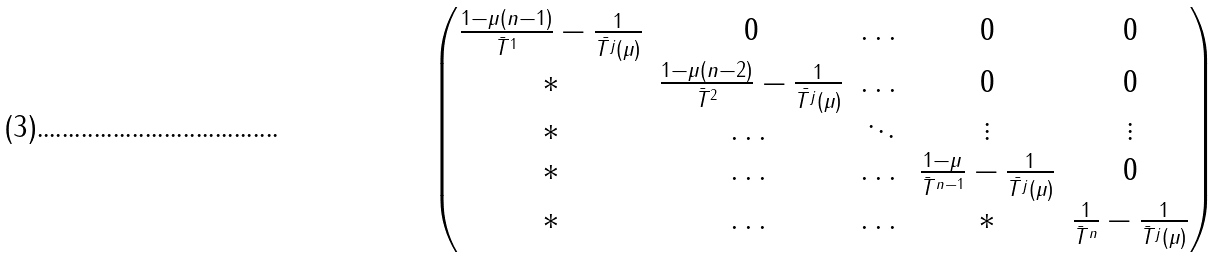<formula> <loc_0><loc_0><loc_500><loc_500>\begin{pmatrix} \frac { 1 - \mu ( n - 1 ) } { \bar { T } ^ { 1 } } - \frac { 1 } { \bar { T ^ { j } } ( \mu ) } & 0 & \dots & 0 & 0 \\ * & \frac { 1 - \mu ( n - 2 ) } { \bar { T } ^ { 2 } } - \frac { 1 } { \bar { T ^ { j } } ( \mu ) } & \dots & 0 & 0 \\ * & \dots & \ddots & \vdots & \vdots \\ * & \dots & \dots & \frac { 1 - \mu } { { \bar { T } ^ { n - 1 } } } - \frac { 1 } { \bar { T ^ { j } } ( \mu ) } & 0 \\ * & \dots & \dots & * & \frac { 1 } { \bar { T } ^ { n } } - \frac { 1 } { { \bar { T } ^ { j } } ( \mu ) } \end{pmatrix}</formula> 